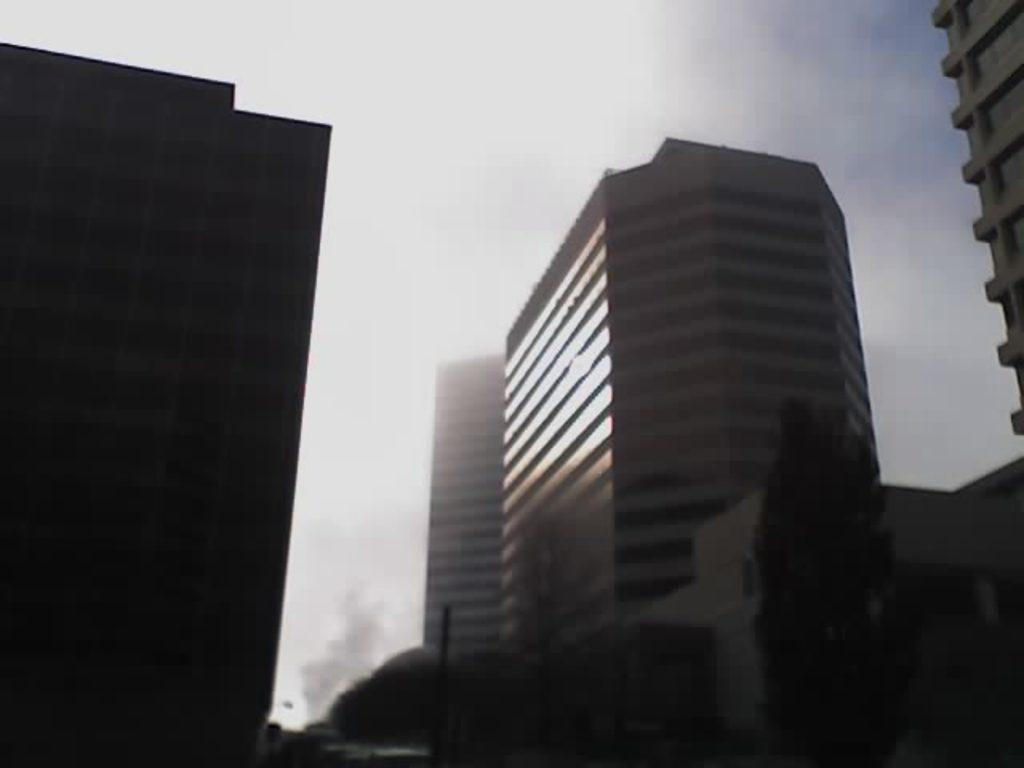Please provide a concise description of this image. In the center of the image there are buildings and trees. In the background there is sky. 